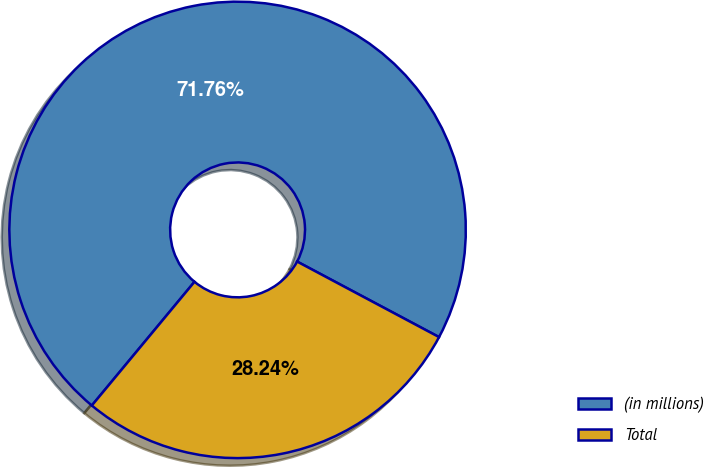Convert chart to OTSL. <chart><loc_0><loc_0><loc_500><loc_500><pie_chart><fcel>(in millions)<fcel>Total<nl><fcel>71.76%<fcel>28.24%<nl></chart> 